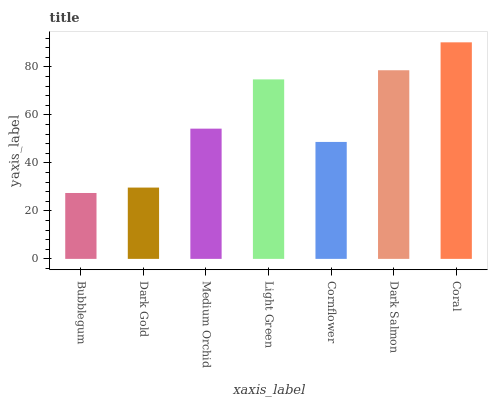Is Bubblegum the minimum?
Answer yes or no. Yes. Is Coral the maximum?
Answer yes or no. Yes. Is Dark Gold the minimum?
Answer yes or no. No. Is Dark Gold the maximum?
Answer yes or no. No. Is Dark Gold greater than Bubblegum?
Answer yes or no. Yes. Is Bubblegum less than Dark Gold?
Answer yes or no. Yes. Is Bubblegum greater than Dark Gold?
Answer yes or no. No. Is Dark Gold less than Bubblegum?
Answer yes or no. No. Is Medium Orchid the high median?
Answer yes or no. Yes. Is Medium Orchid the low median?
Answer yes or no. Yes. Is Light Green the high median?
Answer yes or no. No. Is Cornflower the low median?
Answer yes or no. No. 